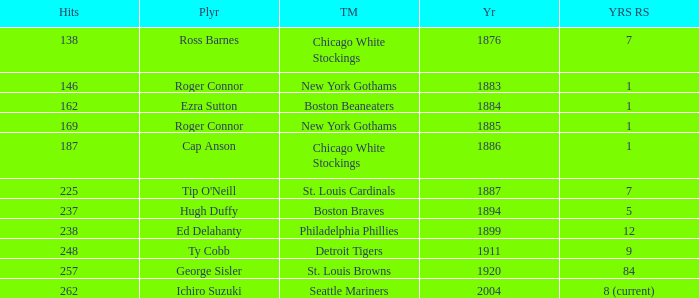Name the hits for years before 1883 138.0. 